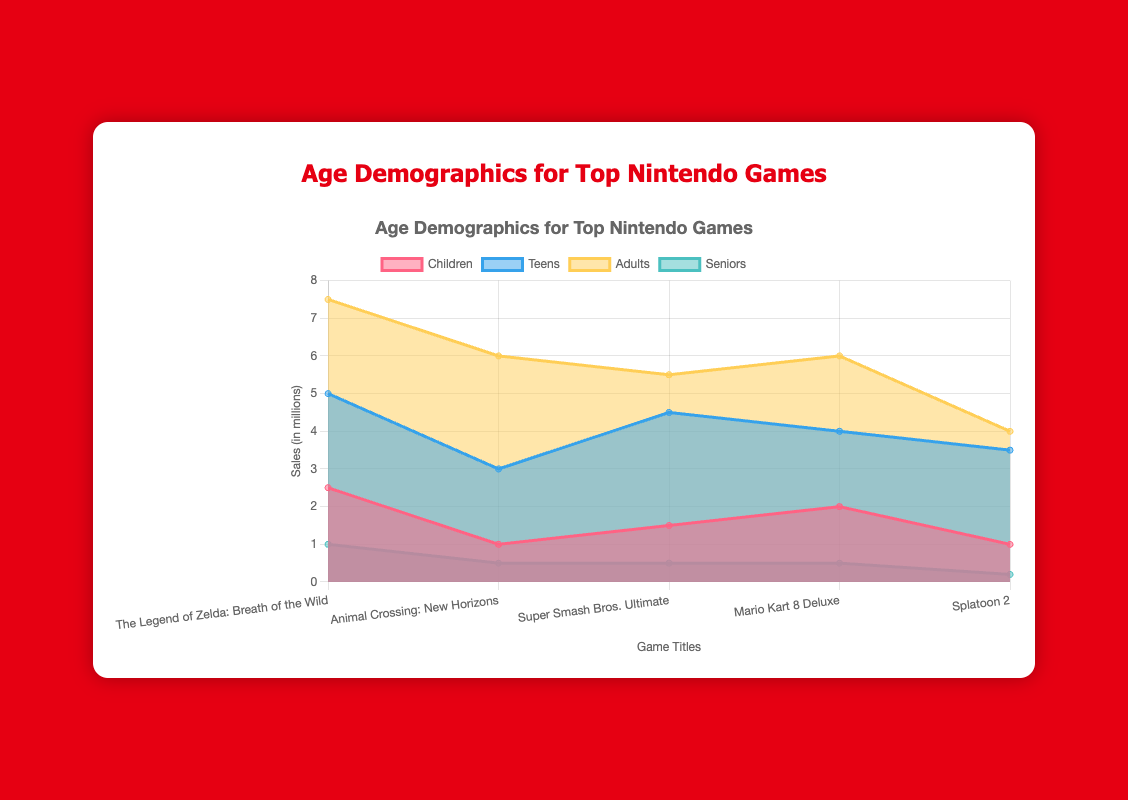What's the title of the chart? The title of the chart is typically placed at the top and clearly summarizes the information shown in the figure. In this case, the title is bold and centered above the chart.
Answer: Age Demographics for Top Nintendo Games How many games are featured in the chart? Count the number of different game titles listed on the x-axis of the chart. This tells us how many unique games are being analyzed.
Answer: 5 Which age demographic has the highest sales for "The Legend of Zelda: Breath of the Wild"? Locate the segment corresponding to "The Legend of Zelda: Breath of the Wild" and compare the heights of the colored areas representing different age groups. The highest segment indicates the largest sales.
Answer: Adults What is the total sales of "Super Smash Bros. Ultimate" across all age demographics? Add the sales numbers for all age demographics for "Super Smash Bros. Ultimate" to get the total. The sales numbers are given for Children (1.5), Teens (4.5), Adults (5.5), and Seniors (0.5).
Answer: 12.0 Which game title has the least sales in the Seniors demographic? Look at the sections representing Seniors for each game title and find the one with the smallest area.
Answer: Splatoon 2 Compare the total sales for the Teens demographic between "Animal Crossing: New Horizons" and "Mario Kart 8 Deluxe". Which one has higher sales? Extract the Teens demographic sales for both games and compare them. "Animal Crossing: New Horizons" has 3.0 million, and "Mario Kart 8 Deluxe" has 4.0 million. Thus, Mario Kart has higher sales.
Answer: Mario Kart 8 Deluxe What is the average sales among the Adults demographic across all games? Calculate the sum of sales in the Adults demographic for all games and divide by the number of games. The values are 7.5 (Zelda), 6.0 (Animal Crossing), 5.5 (Smash Bros), 6.0 (Mario Kart), and 4.0 (Splatoon). Sum = 29.0, Average = 29.0 / 5.
Answer: 5.8 Which game has the highest sales in the Children demographic? Identify the longest segment corresponding to the Children demographic for each game title to determine which has the highest sales.
Answer: The Legend of Zelda: Breath of the Wild 